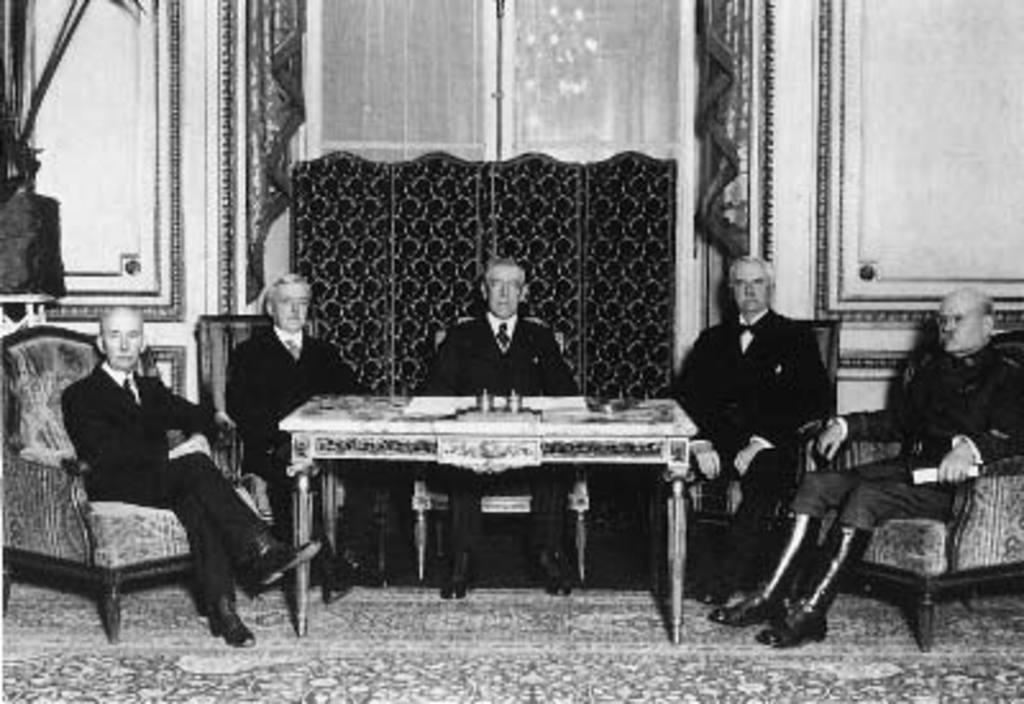Describe this image in one or two sentences. This is completely black and white picture. In this picture we can see five men sitting on chairs in front of a table. 